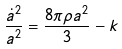Convert formula to latex. <formula><loc_0><loc_0><loc_500><loc_500>\frac { \dot { a } ^ { 2 } } { a ^ { 2 } } = \frac { 8 \pi \rho a ^ { 2 } } { 3 } - k</formula> 